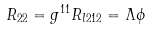Convert formula to latex. <formula><loc_0><loc_0><loc_500><loc_500>R _ { 2 2 } = g ^ { 1 1 } R _ { l 2 1 2 } = { \Lambda } { \phi }</formula> 